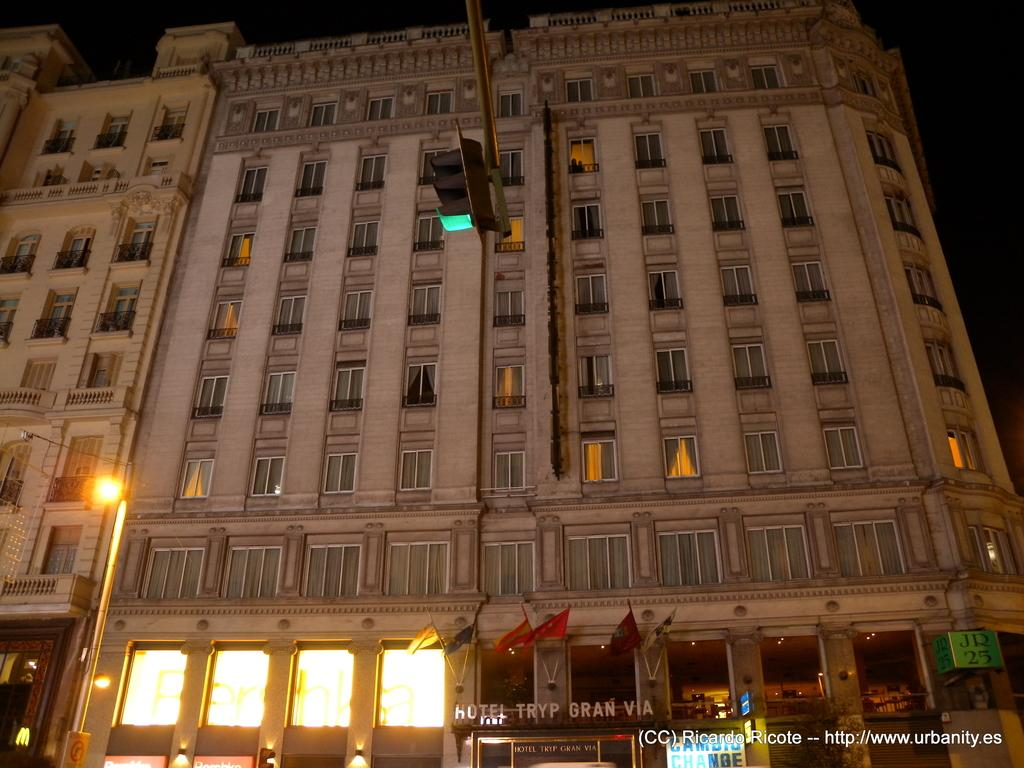What type of structure is visible in the image? There is a building in the image. What features can be seen on the building? The building has lights, flags, windows, and boards. What might the flags represent? The flags on the building could represent a country, organization, or event. What is present at the bottom of the image? There is text at the bottom of the image. What type of quartz can be seen in the image? There is no quartz present in the image. How many sheep are visible in the image? There are no sheep present in the image. 